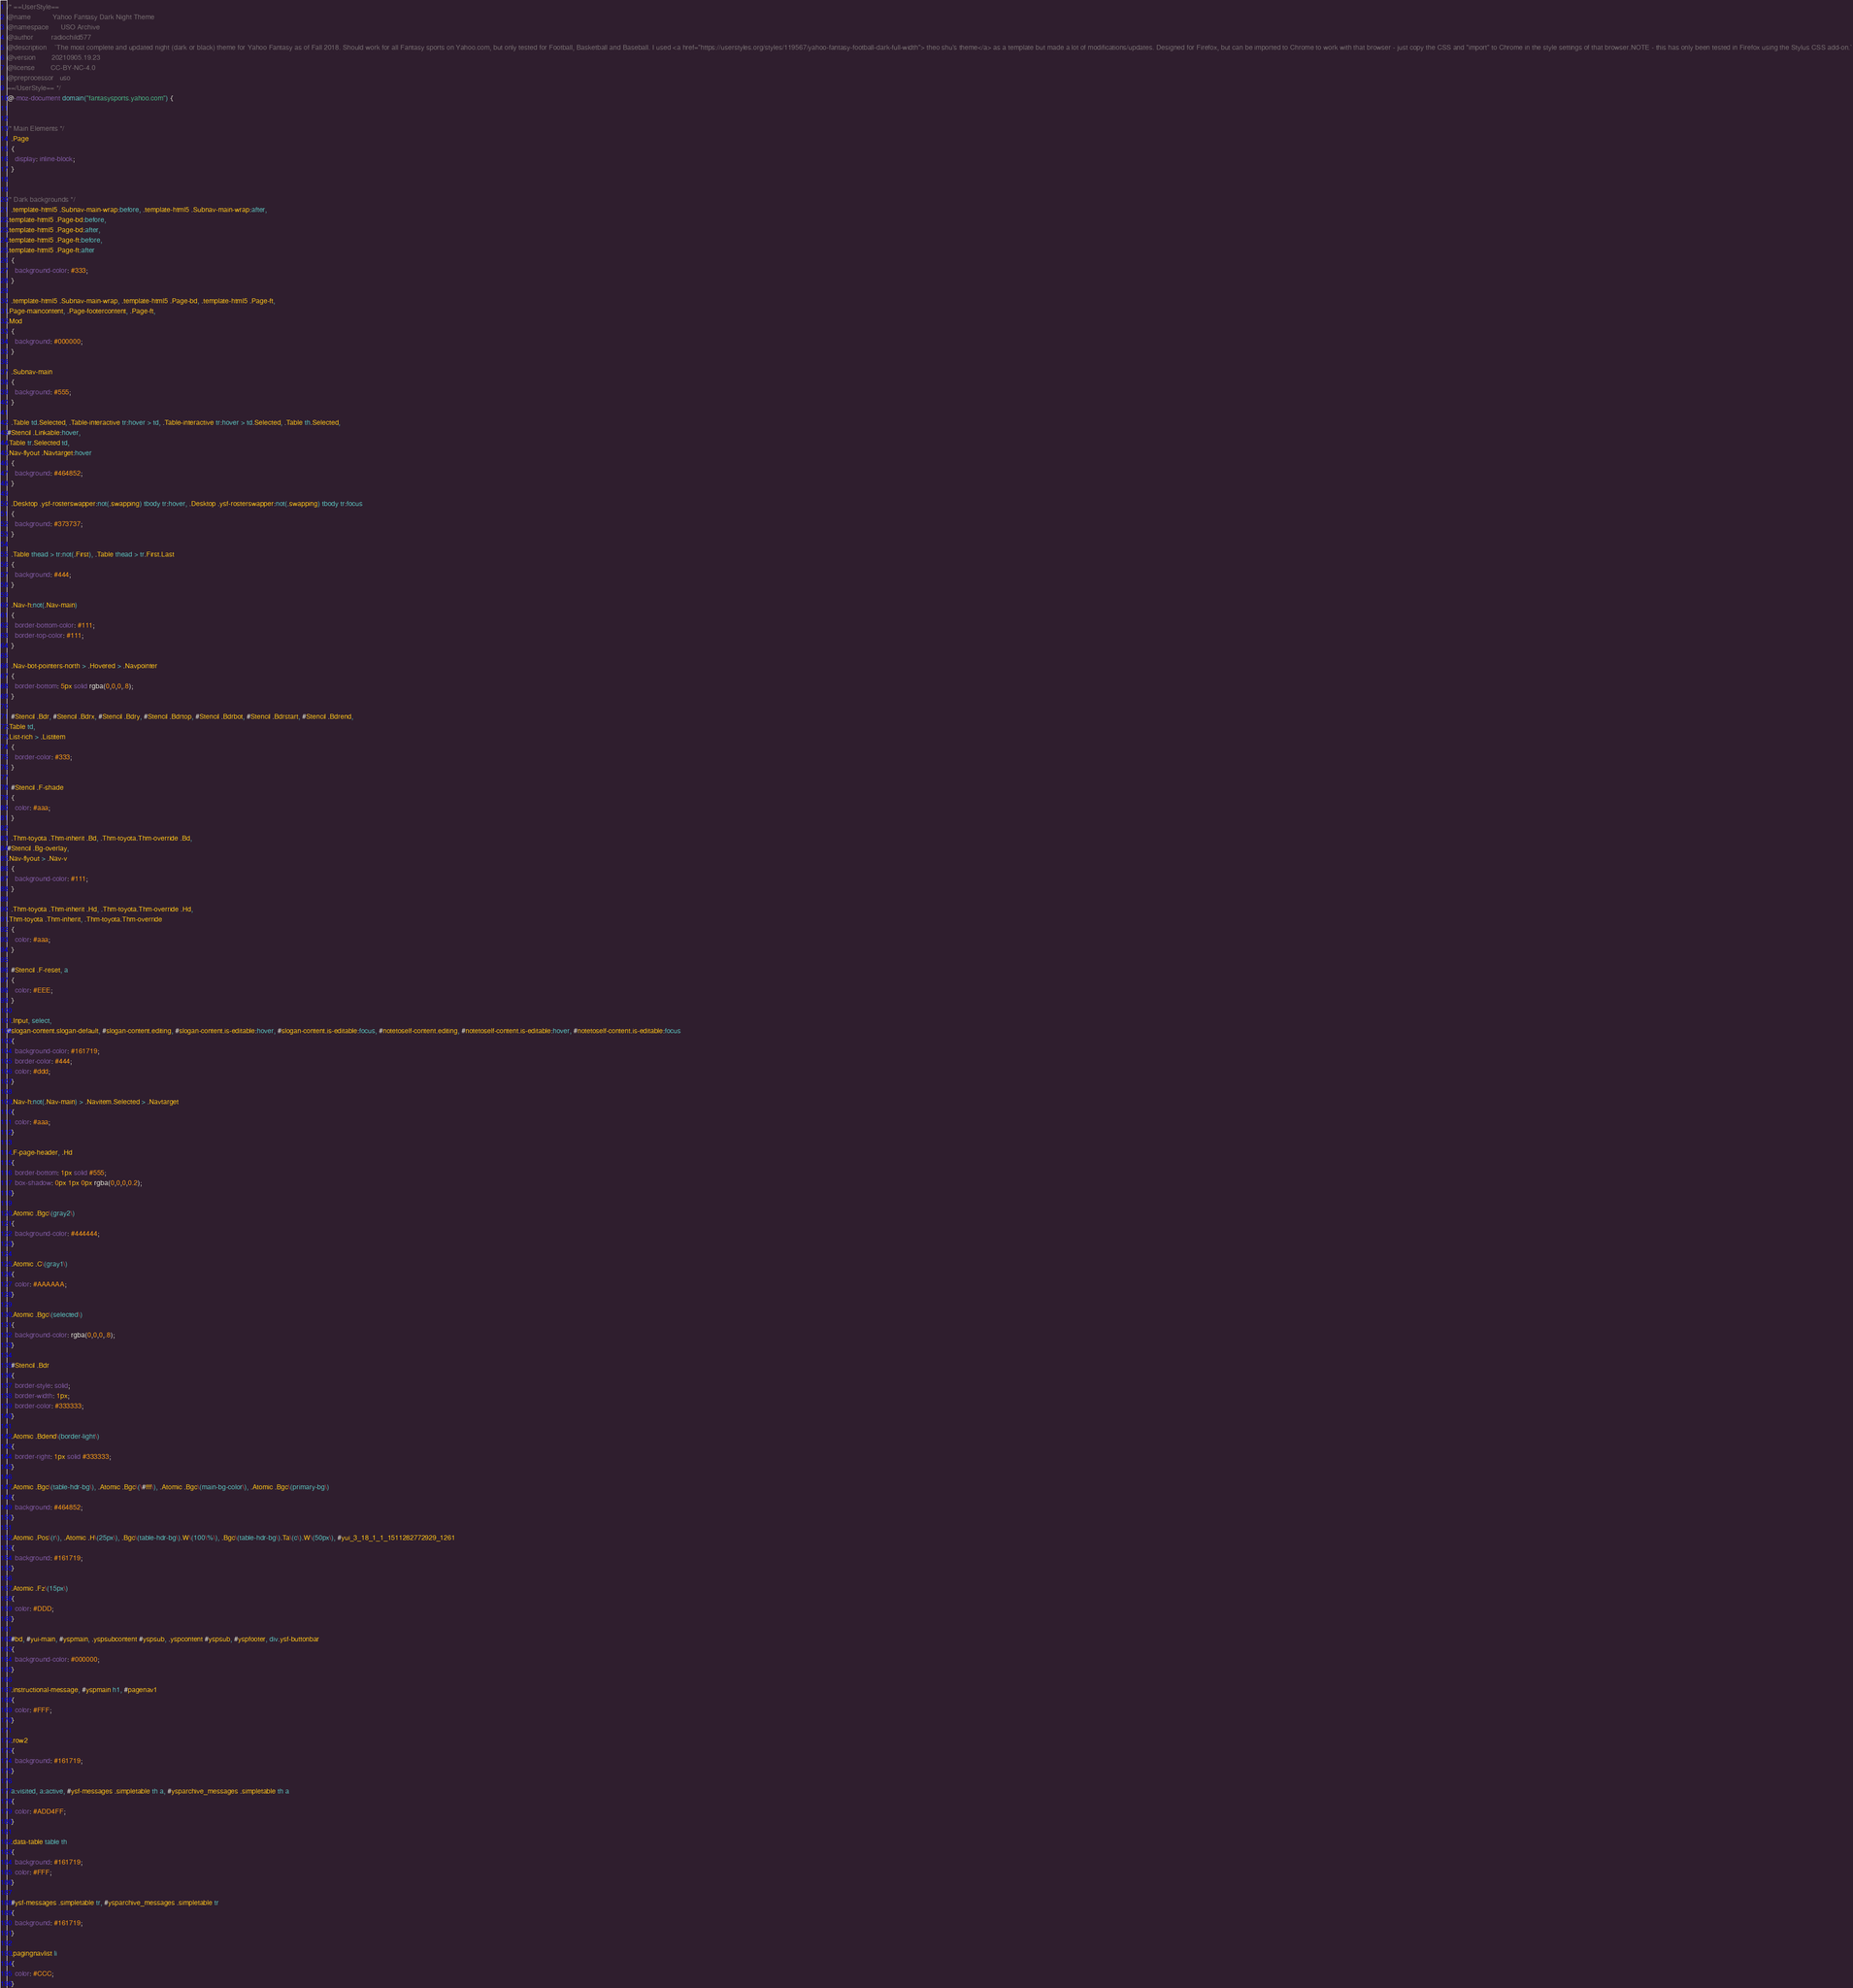Convert code to text. <code><loc_0><loc_0><loc_500><loc_500><_CSS_>/* ==UserStyle==
@name           Yahoo Fantasy Dark Night Theme
@namespace      USO Archive
@author         radiochild577
@description    `The most complete and updated night (dark or black) theme for Yahoo Fantasy as of Fall 2018. Should work for all Fantasy sports on Yahoo.com, but only tested for Football, Basketball and Baseball. I used <a href="https://userstyles.org/styles/119567/yahoo-fantasy-football-dark-full-width"> theo shu's theme</a> as a template but made a lot of modifications/updates. Designed for Firefox, but can be imported to Chrome to work with that browser - just copy the CSS and "import" to Chrome in the style settings of that browser.NOTE - this has only been tested in Firefox using the Stylus CSS add-on.`
@version        20210905.19.23
@license        CC-BY-NC-4.0
@preprocessor   uso
==/UserStyle== */
@-moz-document domain("fantasysports.yahoo.com") {


/* Main Elements */
  .Page
  {
    display: inline-block;
  }


/* Dark backgrounds */
  .template-html5 .Subnav-main-wrap:before, .template-html5 .Subnav-main-wrap:after,
.template-html5 .Page-bd:before,
.template-html5 .Page-bd:after,
.template-html5 .Page-ft:before,
.template-html5 .Page-ft:after
  {
    background-color: #333;
  }

  .template-html5 .Subnav-main-wrap, .template-html5 .Page-bd, .template-html5 .Page-ft,
.Page-maincontent, .Page-footercontent, .Page-ft,
.Mod
  {
    background: #000000;
  }

  .Subnav-main
  {
    background: #555;
  }

  .Table td.Selected, .Table-interactive tr:hover > td, .Table-interactive tr:hover > td.Selected, .Table th.Selected,
#Stencil .Linkable:hover,
.Table tr.Selected td,
.Nav-flyout .Navtarget:hover
  {
    background: #464852;
  }

  .Desktop .ysf-rosterswapper:not(.swapping) tbody tr:hover, .Desktop .ysf-rosterswapper:not(.swapping) tbody tr:focus
  {
    background: #373737;
  }

  .Table thead > tr:not(.First), .Table thead > tr.First.Last
  {
    background: #444;
  }

  .Nav-h:not(.Nav-main)
  {
    border-bottom-color: #111;
    border-top-color: #111;
  }

  .Nav-bot-pointers-north > .Hovered > .Navpointer
  {
    border-bottom: 5px solid rgba(0,0,0,.8);
  }

  #Stencil .Bdr, #Stencil .Bdrx, #Stencil .Bdry, #Stencil .Bdrtop, #Stencil .Bdrbot, #Stencil .Bdrstart, #Stencil .Bdrend,
.Table td,
.List-rich > .Listitem
  {
    border-color: #333;
  }

  #Stencil .F-shade
  {
    color: #aaa;
  }

  .Thm-toyota .Thm-inherit .Bd, .Thm-toyota.Thm-override .Bd,
#Stencil .Bg-overlay,
.Nav-flyout > .Nav-v
  {
    background-color: #111;
  }

  .Thm-toyota .Thm-inherit .Hd, .Thm-toyota.Thm-override .Hd,
.Thm-toyota .Thm-inherit, .Thm-toyota.Thm-override
  {
    color: #aaa;
  }

  #Stencil .F-reset, a
  {
    color: #EEE;
  }

  .Input, select,
#slogan-content.slogan-default, #slogan-content.editing, #slogan-content.is-editable:hover, #slogan-content.is-editable:focus, #notetoself-content.editing, #notetoself-content.is-editable:hover, #notetoself-content.is-editable:focus
  {
    background-color: #161719;
    border-color: #444;
    color: #ddd;
  }

  .Nav-h:not(.Nav-main) > .Navitem.Selected > .Navtarget
  {
    color: #aaa;
  }

  .F-page-header, .Hd
  {
    border-bottom: 1px solid #555;
    box-shadow: 0px 1px 0px rgba(0,0,0,0.2);
  }

  .Atomic .Bgc\(gray2\)
  {
    background-color: #444444;
  }

  .Atomic .C\(gray1\)
  {
    color: #AAAAAA;
  }

  .Atomic .Bgc\(selected\)
  {
    background-color: rgba(0,0,0,.8);
  }

  #Stencil .Bdr
  {
    border-style: solid;
    border-width: 1px;
    border-color: #333333;
  }

  .Atomic .Bdend\(border-light\)
  {
    border-right: 1px solid #333333;
  }

  .Atomic .Bgc\(table-hdr-bg\), .Atomic .Bgc\(\#fff\), .Atomic .Bgc\(main-bg-color\), .Atomic .Bgc\(primary-bg\)
  {
    background: #464852;
  }

  .Atomic .Pos\(r\), .Atomic .H\(25px\), .Bgc\(table-hdr-bg\).W\(100\%\), .Bgc\(table-hdr-bg\).Ta\(c\).W\(50px\), #yui_3_18_1_1_1511282772929_1261
  {
    background: #161719;
  }

  .Atomic .Fz\(15px\)
  {
    color: #DDD;
  }

  #bd, #yui-main, #yspmain, .yspsubcontent #yspsub, .yspcontent #yspsub, #yspfooter, div.ysf-buttonbar
  {
    background-color: #000000;
  }

  .instructional-message, #yspmain h1, #pagenav1
  {
    color: #FFF;
  }

  .row2
  {
    background: #161719;
  }

  a:visited, a:active, #ysf-messages .simpletable th a, #ysparchive_messages .simpletable th a
  {
    color: #ADD4FF;
  }

  .data-table table th
  {
    background: #161719;
    color: #FFF;
  }

  #ysf-messages .simpletable tr, #ysparchive_messages .simpletable tr
  {
    background: #161719;
  }

  .pagingnavlist li
  {
    color: #CCC;
  }</code> 